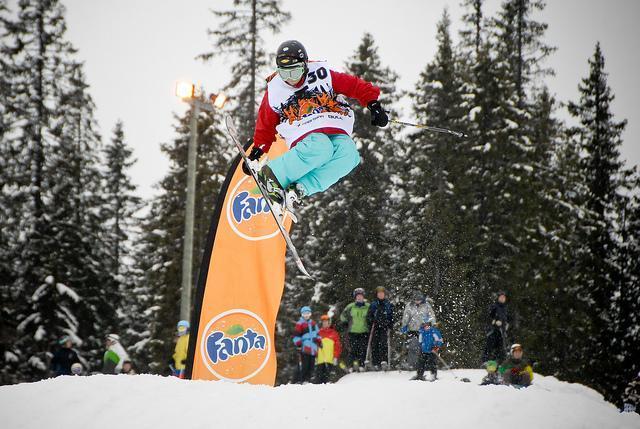How many sheep are sticking their head through the fence?
Give a very brief answer. 0. 